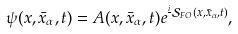<formula> <loc_0><loc_0><loc_500><loc_500>\psi ( x , \bar { x } _ { \alpha } , t ) = A ( x , \bar { x } _ { \alpha } , t ) e ^ { \frac { i } { } \mathcal { S } _ { F O } ( x , \bar { x } _ { \alpha } , t ) } ,</formula> 